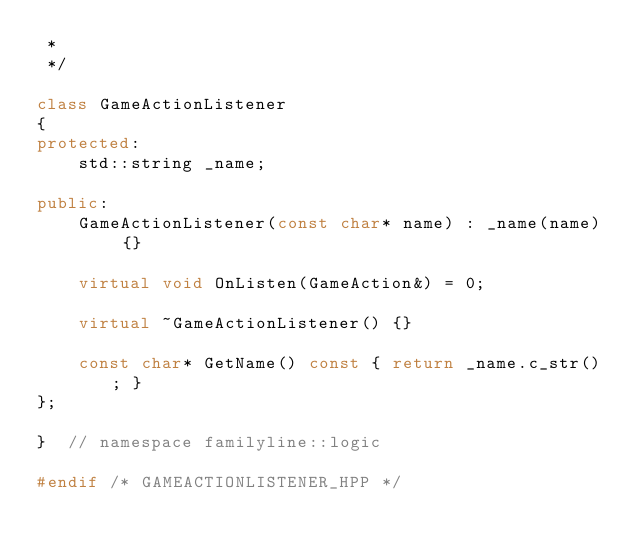<code> <loc_0><loc_0><loc_500><loc_500><_C++_> *
 */

class GameActionListener
{
protected:
    std::string _name;

public:
    GameActionListener(const char* name) : _name(name) {}

    virtual void OnListen(GameAction&) = 0;

    virtual ~GameActionListener() {}

    const char* GetName() const { return _name.c_str(); }
};

}  // namespace familyline::logic

#endif /* GAMEACTIONLISTENER_HPP */
</code> 